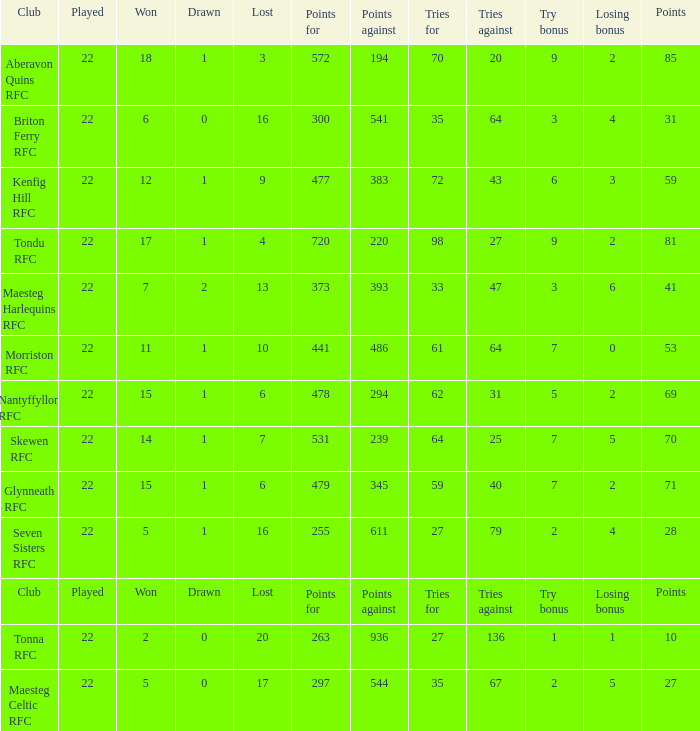What is the value of the points column when the value of the column lost is "lost" Points. 